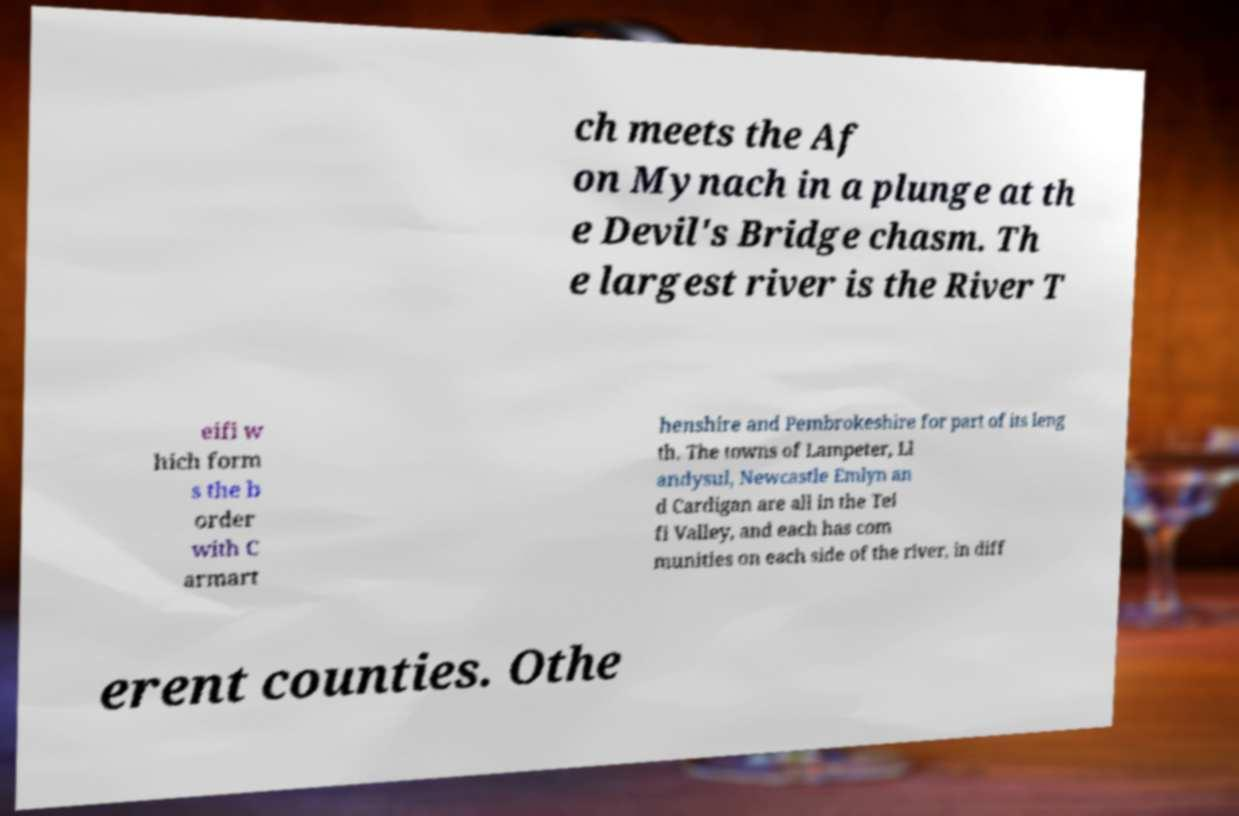There's text embedded in this image that I need extracted. Can you transcribe it verbatim? ch meets the Af on Mynach in a plunge at th e Devil's Bridge chasm. Th e largest river is the River T eifi w hich form s the b order with C armart henshire and Pembrokeshire for part of its leng th. The towns of Lampeter, Ll andysul, Newcastle Emlyn an d Cardigan are all in the Tei fi Valley, and each has com munities on each side of the river, in diff erent counties. Othe 